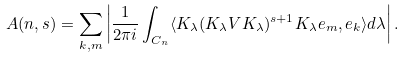<formula> <loc_0><loc_0><loc_500><loc_500>A ( n , s ) = \sum _ { k , m } \left | \frac { 1 } { 2 \pi i } \int _ { C _ { n } } \langle K _ { \lambda } ( K _ { \lambda } V K _ { \lambda } ) ^ { s + 1 } K _ { \lambda } e _ { m } , e _ { k } \rangle d \lambda \right | .</formula> 